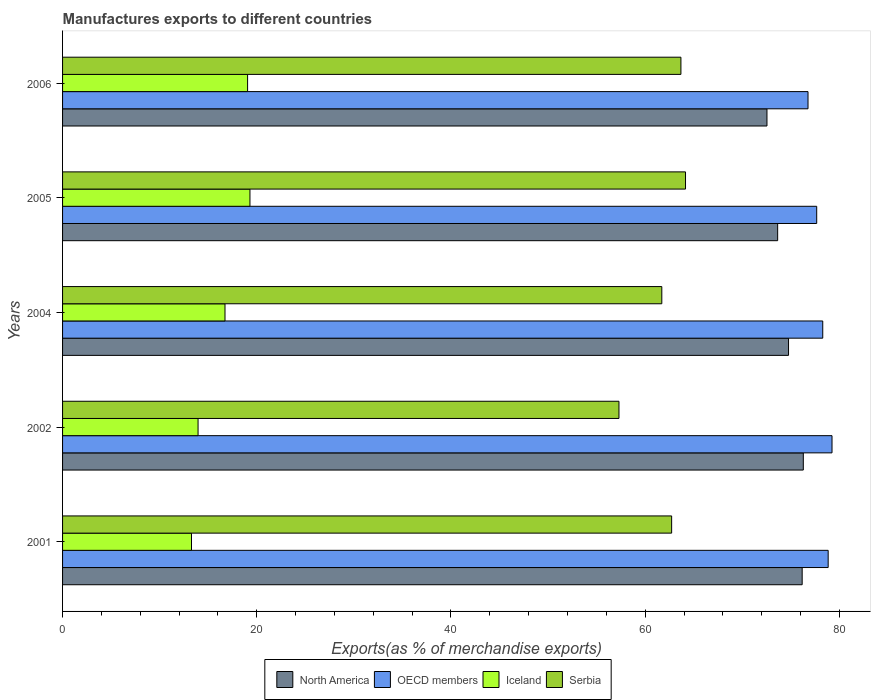Are the number of bars per tick equal to the number of legend labels?
Your answer should be very brief. Yes. How many bars are there on the 1st tick from the top?
Offer a very short reply. 4. In how many cases, is the number of bars for a given year not equal to the number of legend labels?
Ensure brevity in your answer.  0. What is the percentage of exports to different countries in OECD members in 2004?
Make the answer very short. 78.29. Across all years, what is the maximum percentage of exports to different countries in Serbia?
Your response must be concise. 64.15. Across all years, what is the minimum percentage of exports to different countries in North America?
Make the answer very short. 72.54. In which year was the percentage of exports to different countries in North America minimum?
Ensure brevity in your answer.  2006. What is the total percentage of exports to different countries in North America in the graph?
Your answer should be very brief. 373.41. What is the difference between the percentage of exports to different countries in North America in 2002 and that in 2005?
Offer a very short reply. 2.64. What is the difference between the percentage of exports to different countries in North America in 2004 and the percentage of exports to different countries in Serbia in 2002?
Make the answer very short. 17.46. What is the average percentage of exports to different countries in North America per year?
Offer a very short reply. 74.68. In the year 2002, what is the difference between the percentage of exports to different countries in OECD members and percentage of exports to different countries in North America?
Your response must be concise. 2.96. In how many years, is the percentage of exports to different countries in Iceland greater than 56 %?
Make the answer very short. 0. What is the ratio of the percentage of exports to different countries in North America in 2005 to that in 2006?
Provide a succinct answer. 1.02. Is the percentage of exports to different countries in Serbia in 2001 less than that in 2005?
Give a very brief answer. Yes. Is the difference between the percentage of exports to different countries in OECD members in 2004 and 2006 greater than the difference between the percentage of exports to different countries in North America in 2004 and 2006?
Your answer should be very brief. No. What is the difference between the highest and the second highest percentage of exports to different countries in Iceland?
Make the answer very short. 0.24. What is the difference between the highest and the lowest percentage of exports to different countries in Iceland?
Provide a succinct answer. 6.02. Is the sum of the percentage of exports to different countries in OECD members in 2004 and 2005 greater than the maximum percentage of exports to different countries in Iceland across all years?
Your response must be concise. Yes. What does the 4th bar from the bottom in 2006 represents?
Your answer should be very brief. Serbia. Are all the bars in the graph horizontal?
Your response must be concise. Yes. Are the values on the major ticks of X-axis written in scientific E-notation?
Give a very brief answer. No. Does the graph contain any zero values?
Provide a short and direct response. No. Does the graph contain grids?
Provide a succinct answer. No. Where does the legend appear in the graph?
Make the answer very short. Bottom center. How are the legend labels stacked?
Your answer should be compact. Horizontal. What is the title of the graph?
Provide a short and direct response. Manufactures exports to different countries. What is the label or title of the X-axis?
Your answer should be compact. Exports(as % of merchandise exports). What is the Exports(as % of merchandise exports) in North America in 2001?
Provide a short and direct response. 76.17. What is the Exports(as % of merchandise exports) in OECD members in 2001?
Keep it short and to the point. 78.85. What is the Exports(as % of merchandise exports) in Iceland in 2001?
Provide a short and direct response. 13.28. What is the Exports(as % of merchandise exports) in Serbia in 2001?
Make the answer very short. 62.73. What is the Exports(as % of merchandise exports) in North America in 2002?
Provide a short and direct response. 76.29. What is the Exports(as % of merchandise exports) in OECD members in 2002?
Ensure brevity in your answer.  79.24. What is the Exports(as % of merchandise exports) of Iceland in 2002?
Provide a short and direct response. 13.95. What is the Exports(as % of merchandise exports) of Serbia in 2002?
Provide a short and direct response. 57.3. What is the Exports(as % of merchandise exports) in North America in 2004?
Ensure brevity in your answer.  74.76. What is the Exports(as % of merchandise exports) of OECD members in 2004?
Ensure brevity in your answer.  78.29. What is the Exports(as % of merchandise exports) of Iceland in 2004?
Ensure brevity in your answer.  16.73. What is the Exports(as % of merchandise exports) of Serbia in 2004?
Ensure brevity in your answer.  61.71. What is the Exports(as % of merchandise exports) in North America in 2005?
Provide a succinct answer. 73.64. What is the Exports(as % of merchandise exports) of OECD members in 2005?
Your answer should be compact. 77.67. What is the Exports(as % of merchandise exports) of Iceland in 2005?
Provide a succinct answer. 19.3. What is the Exports(as % of merchandise exports) of Serbia in 2005?
Provide a short and direct response. 64.15. What is the Exports(as % of merchandise exports) of North America in 2006?
Offer a very short reply. 72.54. What is the Exports(as % of merchandise exports) of OECD members in 2006?
Your response must be concise. 76.77. What is the Exports(as % of merchandise exports) in Iceland in 2006?
Ensure brevity in your answer.  19.05. What is the Exports(as % of merchandise exports) in Serbia in 2006?
Ensure brevity in your answer.  63.68. Across all years, what is the maximum Exports(as % of merchandise exports) in North America?
Your response must be concise. 76.29. Across all years, what is the maximum Exports(as % of merchandise exports) of OECD members?
Make the answer very short. 79.24. Across all years, what is the maximum Exports(as % of merchandise exports) in Iceland?
Keep it short and to the point. 19.3. Across all years, what is the maximum Exports(as % of merchandise exports) in Serbia?
Provide a short and direct response. 64.15. Across all years, what is the minimum Exports(as % of merchandise exports) in North America?
Your answer should be compact. 72.54. Across all years, what is the minimum Exports(as % of merchandise exports) in OECD members?
Your answer should be very brief. 76.77. Across all years, what is the minimum Exports(as % of merchandise exports) of Iceland?
Provide a succinct answer. 13.28. Across all years, what is the minimum Exports(as % of merchandise exports) in Serbia?
Keep it short and to the point. 57.3. What is the total Exports(as % of merchandise exports) in North America in the graph?
Your answer should be compact. 373.41. What is the total Exports(as % of merchandise exports) in OECD members in the graph?
Your answer should be compact. 390.82. What is the total Exports(as % of merchandise exports) in Iceland in the graph?
Your answer should be compact. 82.31. What is the total Exports(as % of merchandise exports) of Serbia in the graph?
Give a very brief answer. 309.58. What is the difference between the Exports(as % of merchandise exports) of North America in 2001 and that in 2002?
Your answer should be very brief. -0.12. What is the difference between the Exports(as % of merchandise exports) of OECD members in 2001 and that in 2002?
Make the answer very short. -0.4. What is the difference between the Exports(as % of merchandise exports) in Iceland in 2001 and that in 2002?
Make the answer very short. -0.68. What is the difference between the Exports(as % of merchandise exports) of Serbia in 2001 and that in 2002?
Your answer should be very brief. 5.42. What is the difference between the Exports(as % of merchandise exports) in North America in 2001 and that in 2004?
Provide a succinct answer. 1.4. What is the difference between the Exports(as % of merchandise exports) of OECD members in 2001 and that in 2004?
Provide a succinct answer. 0.56. What is the difference between the Exports(as % of merchandise exports) in Iceland in 2001 and that in 2004?
Your answer should be compact. -3.45. What is the difference between the Exports(as % of merchandise exports) in Serbia in 2001 and that in 2004?
Ensure brevity in your answer.  1.01. What is the difference between the Exports(as % of merchandise exports) of North America in 2001 and that in 2005?
Your answer should be compact. 2.52. What is the difference between the Exports(as % of merchandise exports) of OECD members in 2001 and that in 2005?
Your answer should be very brief. 1.18. What is the difference between the Exports(as % of merchandise exports) of Iceland in 2001 and that in 2005?
Give a very brief answer. -6.02. What is the difference between the Exports(as % of merchandise exports) in Serbia in 2001 and that in 2005?
Ensure brevity in your answer.  -1.43. What is the difference between the Exports(as % of merchandise exports) of North America in 2001 and that in 2006?
Your answer should be very brief. 3.63. What is the difference between the Exports(as % of merchandise exports) of OECD members in 2001 and that in 2006?
Your response must be concise. 2.08. What is the difference between the Exports(as % of merchandise exports) in Iceland in 2001 and that in 2006?
Your answer should be very brief. -5.78. What is the difference between the Exports(as % of merchandise exports) in Serbia in 2001 and that in 2006?
Ensure brevity in your answer.  -0.96. What is the difference between the Exports(as % of merchandise exports) in North America in 2002 and that in 2004?
Your answer should be compact. 1.52. What is the difference between the Exports(as % of merchandise exports) of OECD members in 2002 and that in 2004?
Provide a short and direct response. 0.95. What is the difference between the Exports(as % of merchandise exports) in Iceland in 2002 and that in 2004?
Your response must be concise. -2.77. What is the difference between the Exports(as % of merchandise exports) in Serbia in 2002 and that in 2004?
Your response must be concise. -4.41. What is the difference between the Exports(as % of merchandise exports) of North America in 2002 and that in 2005?
Ensure brevity in your answer.  2.64. What is the difference between the Exports(as % of merchandise exports) of OECD members in 2002 and that in 2005?
Make the answer very short. 1.58. What is the difference between the Exports(as % of merchandise exports) of Iceland in 2002 and that in 2005?
Your response must be concise. -5.34. What is the difference between the Exports(as % of merchandise exports) of Serbia in 2002 and that in 2005?
Your answer should be very brief. -6.85. What is the difference between the Exports(as % of merchandise exports) in North America in 2002 and that in 2006?
Your answer should be compact. 3.74. What is the difference between the Exports(as % of merchandise exports) in OECD members in 2002 and that in 2006?
Ensure brevity in your answer.  2.47. What is the difference between the Exports(as % of merchandise exports) in Iceland in 2002 and that in 2006?
Provide a short and direct response. -5.1. What is the difference between the Exports(as % of merchandise exports) in Serbia in 2002 and that in 2006?
Provide a succinct answer. -6.38. What is the difference between the Exports(as % of merchandise exports) in North America in 2004 and that in 2005?
Provide a short and direct response. 1.12. What is the difference between the Exports(as % of merchandise exports) of OECD members in 2004 and that in 2005?
Make the answer very short. 0.62. What is the difference between the Exports(as % of merchandise exports) of Iceland in 2004 and that in 2005?
Your answer should be very brief. -2.57. What is the difference between the Exports(as % of merchandise exports) of Serbia in 2004 and that in 2005?
Your answer should be very brief. -2.44. What is the difference between the Exports(as % of merchandise exports) in North America in 2004 and that in 2006?
Your answer should be very brief. 2.22. What is the difference between the Exports(as % of merchandise exports) in OECD members in 2004 and that in 2006?
Your answer should be very brief. 1.52. What is the difference between the Exports(as % of merchandise exports) of Iceland in 2004 and that in 2006?
Provide a succinct answer. -2.33. What is the difference between the Exports(as % of merchandise exports) in Serbia in 2004 and that in 2006?
Provide a short and direct response. -1.97. What is the difference between the Exports(as % of merchandise exports) in North America in 2005 and that in 2006?
Ensure brevity in your answer.  1.1. What is the difference between the Exports(as % of merchandise exports) in OECD members in 2005 and that in 2006?
Ensure brevity in your answer.  0.89. What is the difference between the Exports(as % of merchandise exports) of Iceland in 2005 and that in 2006?
Ensure brevity in your answer.  0.24. What is the difference between the Exports(as % of merchandise exports) in Serbia in 2005 and that in 2006?
Offer a very short reply. 0.47. What is the difference between the Exports(as % of merchandise exports) of North America in 2001 and the Exports(as % of merchandise exports) of OECD members in 2002?
Provide a succinct answer. -3.07. What is the difference between the Exports(as % of merchandise exports) of North America in 2001 and the Exports(as % of merchandise exports) of Iceland in 2002?
Keep it short and to the point. 62.22. What is the difference between the Exports(as % of merchandise exports) in North America in 2001 and the Exports(as % of merchandise exports) in Serbia in 2002?
Your answer should be very brief. 18.87. What is the difference between the Exports(as % of merchandise exports) of OECD members in 2001 and the Exports(as % of merchandise exports) of Iceland in 2002?
Ensure brevity in your answer.  64.89. What is the difference between the Exports(as % of merchandise exports) in OECD members in 2001 and the Exports(as % of merchandise exports) in Serbia in 2002?
Your answer should be very brief. 21.54. What is the difference between the Exports(as % of merchandise exports) of Iceland in 2001 and the Exports(as % of merchandise exports) of Serbia in 2002?
Your response must be concise. -44.02. What is the difference between the Exports(as % of merchandise exports) in North America in 2001 and the Exports(as % of merchandise exports) in OECD members in 2004?
Offer a very short reply. -2.12. What is the difference between the Exports(as % of merchandise exports) in North America in 2001 and the Exports(as % of merchandise exports) in Iceland in 2004?
Ensure brevity in your answer.  59.44. What is the difference between the Exports(as % of merchandise exports) in North America in 2001 and the Exports(as % of merchandise exports) in Serbia in 2004?
Offer a very short reply. 14.46. What is the difference between the Exports(as % of merchandise exports) in OECD members in 2001 and the Exports(as % of merchandise exports) in Iceland in 2004?
Provide a short and direct response. 62.12. What is the difference between the Exports(as % of merchandise exports) of OECD members in 2001 and the Exports(as % of merchandise exports) of Serbia in 2004?
Offer a terse response. 17.13. What is the difference between the Exports(as % of merchandise exports) of Iceland in 2001 and the Exports(as % of merchandise exports) of Serbia in 2004?
Provide a succinct answer. -48.44. What is the difference between the Exports(as % of merchandise exports) in North America in 2001 and the Exports(as % of merchandise exports) in OECD members in 2005?
Provide a succinct answer. -1.5. What is the difference between the Exports(as % of merchandise exports) of North America in 2001 and the Exports(as % of merchandise exports) of Iceland in 2005?
Your response must be concise. 56.87. What is the difference between the Exports(as % of merchandise exports) of North America in 2001 and the Exports(as % of merchandise exports) of Serbia in 2005?
Your response must be concise. 12.01. What is the difference between the Exports(as % of merchandise exports) of OECD members in 2001 and the Exports(as % of merchandise exports) of Iceland in 2005?
Provide a short and direct response. 59.55. What is the difference between the Exports(as % of merchandise exports) of OECD members in 2001 and the Exports(as % of merchandise exports) of Serbia in 2005?
Give a very brief answer. 14.69. What is the difference between the Exports(as % of merchandise exports) of Iceland in 2001 and the Exports(as % of merchandise exports) of Serbia in 2005?
Your response must be concise. -50.88. What is the difference between the Exports(as % of merchandise exports) of North America in 2001 and the Exports(as % of merchandise exports) of OECD members in 2006?
Provide a succinct answer. -0.6. What is the difference between the Exports(as % of merchandise exports) in North America in 2001 and the Exports(as % of merchandise exports) in Iceland in 2006?
Offer a terse response. 57.11. What is the difference between the Exports(as % of merchandise exports) in North America in 2001 and the Exports(as % of merchandise exports) in Serbia in 2006?
Provide a short and direct response. 12.49. What is the difference between the Exports(as % of merchandise exports) of OECD members in 2001 and the Exports(as % of merchandise exports) of Iceland in 2006?
Provide a short and direct response. 59.79. What is the difference between the Exports(as % of merchandise exports) in OECD members in 2001 and the Exports(as % of merchandise exports) in Serbia in 2006?
Offer a terse response. 15.16. What is the difference between the Exports(as % of merchandise exports) in Iceland in 2001 and the Exports(as % of merchandise exports) in Serbia in 2006?
Ensure brevity in your answer.  -50.4. What is the difference between the Exports(as % of merchandise exports) of North America in 2002 and the Exports(as % of merchandise exports) of OECD members in 2004?
Your response must be concise. -2. What is the difference between the Exports(as % of merchandise exports) of North America in 2002 and the Exports(as % of merchandise exports) of Iceland in 2004?
Provide a succinct answer. 59.56. What is the difference between the Exports(as % of merchandise exports) of North America in 2002 and the Exports(as % of merchandise exports) of Serbia in 2004?
Your answer should be compact. 14.57. What is the difference between the Exports(as % of merchandise exports) in OECD members in 2002 and the Exports(as % of merchandise exports) in Iceland in 2004?
Make the answer very short. 62.51. What is the difference between the Exports(as % of merchandise exports) in OECD members in 2002 and the Exports(as % of merchandise exports) in Serbia in 2004?
Provide a short and direct response. 17.53. What is the difference between the Exports(as % of merchandise exports) in Iceland in 2002 and the Exports(as % of merchandise exports) in Serbia in 2004?
Your answer should be very brief. -47.76. What is the difference between the Exports(as % of merchandise exports) in North America in 2002 and the Exports(as % of merchandise exports) in OECD members in 2005?
Provide a short and direct response. -1.38. What is the difference between the Exports(as % of merchandise exports) of North America in 2002 and the Exports(as % of merchandise exports) of Iceland in 2005?
Your answer should be compact. 56.99. What is the difference between the Exports(as % of merchandise exports) of North America in 2002 and the Exports(as % of merchandise exports) of Serbia in 2005?
Your answer should be compact. 12.13. What is the difference between the Exports(as % of merchandise exports) in OECD members in 2002 and the Exports(as % of merchandise exports) in Iceland in 2005?
Ensure brevity in your answer.  59.94. What is the difference between the Exports(as % of merchandise exports) of OECD members in 2002 and the Exports(as % of merchandise exports) of Serbia in 2005?
Offer a very short reply. 15.09. What is the difference between the Exports(as % of merchandise exports) in Iceland in 2002 and the Exports(as % of merchandise exports) in Serbia in 2005?
Your answer should be very brief. -50.2. What is the difference between the Exports(as % of merchandise exports) in North America in 2002 and the Exports(as % of merchandise exports) in OECD members in 2006?
Your answer should be very brief. -0.49. What is the difference between the Exports(as % of merchandise exports) in North America in 2002 and the Exports(as % of merchandise exports) in Iceland in 2006?
Ensure brevity in your answer.  57.23. What is the difference between the Exports(as % of merchandise exports) in North America in 2002 and the Exports(as % of merchandise exports) in Serbia in 2006?
Give a very brief answer. 12.6. What is the difference between the Exports(as % of merchandise exports) of OECD members in 2002 and the Exports(as % of merchandise exports) of Iceland in 2006?
Ensure brevity in your answer.  60.19. What is the difference between the Exports(as % of merchandise exports) in OECD members in 2002 and the Exports(as % of merchandise exports) in Serbia in 2006?
Give a very brief answer. 15.56. What is the difference between the Exports(as % of merchandise exports) of Iceland in 2002 and the Exports(as % of merchandise exports) of Serbia in 2006?
Give a very brief answer. -49.73. What is the difference between the Exports(as % of merchandise exports) of North America in 2004 and the Exports(as % of merchandise exports) of OECD members in 2005?
Provide a succinct answer. -2.9. What is the difference between the Exports(as % of merchandise exports) in North America in 2004 and the Exports(as % of merchandise exports) in Iceland in 2005?
Keep it short and to the point. 55.47. What is the difference between the Exports(as % of merchandise exports) of North America in 2004 and the Exports(as % of merchandise exports) of Serbia in 2005?
Your response must be concise. 10.61. What is the difference between the Exports(as % of merchandise exports) of OECD members in 2004 and the Exports(as % of merchandise exports) of Iceland in 2005?
Make the answer very short. 58.99. What is the difference between the Exports(as % of merchandise exports) in OECD members in 2004 and the Exports(as % of merchandise exports) in Serbia in 2005?
Offer a terse response. 14.13. What is the difference between the Exports(as % of merchandise exports) of Iceland in 2004 and the Exports(as % of merchandise exports) of Serbia in 2005?
Provide a succinct answer. -47.43. What is the difference between the Exports(as % of merchandise exports) of North America in 2004 and the Exports(as % of merchandise exports) of OECD members in 2006?
Ensure brevity in your answer.  -2.01. What is the difference between the Exports(as % of merchandise exports) of North America in 2004 and the Exports(as % of merchandise exports) of Iceland in 2006?
Ensure brevity in your answer.  55.71. What is the difference between the Exports(as % of merchandise exports) in North America in 2004 and the Exports(as % of merchandise exports) in Serbia in 2006?
Give a very brief answer. 11.08. What is the difference between the Exports(as % of merchandise exports) in OECD members in 2004 and the Exports(as % of merchandise exports) in Iceland in 2006?
Provide a short and direct response. 59.23. What is the difference between the Exports(as % of merchandise exports) in OECD members in 2004 and the Exports(as % of merchandise exports) in Serbia in 2006?
Offer a very short reply. 14.61. What is the difference between the Exports(as % of merchandise exports) in Iceland in 2004 and the Exports(as % of merchandise exports) in Serbia in 2006?
Offer a very short reply. -46.95. What is the difference between the Exports(as % of merchandise exports) of North America in 2005 and the Exports(as % of merchandise exports) of OECD members in 2006?
Your answer should be very brief. -3.13. What is the difference between the Exports(as % of merchandise exports) of North America in 2005 and the Exports(as % of merchandise exports) of Iceland in 2006?
Your response must be concise. 54.59. What is the difference between the Exports(as % of merchandise exports) of North America in 2005 and the Exports(as % of merchandise exports) of Serbia in 2006?
Offer a very short reply. 9.96. What is the difference between the Exports(as % of merchandise exports) in OECD members in 2005 and the Exports(as % of merchandise exports) in Iceland in 2006?
Your answer should be compact. 58.61. What is the difference between the Exports(as % of merchandise exports) in OECD members in 2005 and the Exports(as % of merchandise exports) in Serbia in 2006?
Your response must be concise. 13.98. What is the difference between the Exports(as % of merchandise exports) in Iceland in 2005 and the Exports(as % of merchandise exports) in Serbia in 2006?
Offer a terse response. -44.38. What is the average Exports(as % of merchandise exports) of North America per year?
Provide a succinct answer. 74.68. What is the average Exports(as % of merchandise exports) of OECD members per year?
Your answer should be very brief. 78.16. What is the average Exports(as % of merchandise exports) in Iceland per year?
Ensure brevity in your answer.  16.46. What is the average Exports(as % of merchandise exports) of Serbia per year?
Your response must be concise. 61.92. In the year 2001, what is the difference between the Exports(as % of merchandise exports) of North America and Exports(as % of merchandise exports) of OECD members?
Provide a short and direct response. -2.68. In the year 2001, what is the difference between the Exports(as % of merchandise exports) in North America and Exports(as % of merchandise exports) in Iceland?
Give a very brief answer. 62.89. In the year 2001, what is the difference between the Exports(as % of merchandise exports) of North America and Exports(as % of merchandise exports) of Serbia?
Offer a very short reply. 13.44. In the year 2001, what is the difference between the Exports(as % of merchandise exports) of OECD members and Exports(as % of merchandise exports) of Iceland?
Your response must be concise. 65.57. In the year 2001, what is the difference between the Exports(as % of merchandise exports) of OECD members and Exports(as % of merchandise exports) of Serbia?
Your answer should be very brief. 16.12. In the year 2001, what is the difference between the Exports(as % of merchandise exports) of Iceland and Exports(as % of merchandise exports) of Serbia?
Ensure brevity in your answer.  -49.45. In the year 2002, what is the difference between the Exports(as % of merchandise exports) of North America and Exports(as % of merchandise exports) of OECD members?
Your response must be concise. -2.96. In the year 2002, what is the difference between the Exports(as % of merchandise exports) of North America and Exports(as % of merchandise exports) of Iceland?
Provide a succinct answer. 62.33. In the year 2002, what is the difference between the Exports(as % of merchandise exports) in North America and Exports(as % of merchandise exports) in Serbia?
Provide a short and direct response. 18.98. In the year 2002, what is the difference between the Exports(as % of merchandise exports) in OECD members and Exports(as % of merchandise exports) in Iceland?
Ensure brevity in your answer.  65.29. In the year 2002, what is the difference between the Exports(as % of merchandise exports) of OECD members and Exports(as % of merchandise exports) of Serbia?
Make the answer very short. 21.94. In the year 2002, what is the difference between the Exports(as % of merchandise exports) of Iceland and Exports(as % of merchandise exports) of Serbia?
Provide a succinct answer. -43.35. In the year 2004, what is the difference between the Exports(as % of merchandise exports) in North America and Exports(as % of merchandise exports) in OECD members?
Give a very brief answer. -3.52. In the year 2004, what is the difference between the Exports(as % of merchandise exports) of North America and Exports(as % of merchandise exports) of Iceland?
Provide a short and direct response. 58.04. In the year 2004, what is the difference between the Exports(as % of merchandise exports) in North America and Exports(as % of merchandise exports) in Serbia?
Give a very brief answer. 13.05. In the year 2004, what is the difference between the Exports(as % of merchandise exports) of OECD members and Exports(as % of merchandise exports) of Iceland?
Make the answer very short. 61.56. In the year 2004, what is the difference between the Exports(as % of merchandise exports) of OECD members and Exports(as % of merchandise exports) of Serbia?
Keep it short and to the point. 16.58. In the year 2004, what is the difference between the Exports(as % of merchandise exports) in Iceland and Exports(as % of merchandise exports) in Serbia?
Make the answer very short. -44.98. In the year 2005, what is the difference between the Exports(as % of merchandise exports) in North America and Exports(as % of merchandise exports) in OECD members?
Offer a very short reply. -4.02. In the year 2005, what is the difference between the Exports(as % of merchandise exports) of North America and Exports(as % of merchandise exports) of Iceland?
Provide a succinct answer. 54.35. In the year 2005, what is the difference between the Exports(as % of merchandise exports) of North America and Exports(as % of merchandise exports) of Serbia?
Offer a terse response. 9.49. In the year 2005, what is the difference between the Exports(as % of merchandise exports) in OECD members and Exports(as % of merchandise exports) in Iceland?
Offer a very short reply. 58.37. In the year 2005, what is the difference between the Exports(as % of merchandise exports) of OECD members and Exports(as % of merchandise exports) of Serbia?
Make the answer very short. 13.51. In the year 2005, what is the difference between the Exports(as % of merchandise exports) in Iceland and Exports(as % of merchandise exports) in Serbia?
Ensure brevity in your answer.  -44.86. In the year 2006, what is the difference between the Exports(as % of merchandise exports) in North America and Exports(as % of merchandise exports) in OECD members?
Offer a very short reply. -4.23. In the year 2006, what is the difference between the Exports(as % of merchandise exports) in North America and Exports(as % of merchandise exports) in Iceland?
Provide a short and direct response. 53.49. In the year 2006, what is the difference between the Exports(as % of merchandise exports) in North America and Exports(as % of merchandise exports) in Serbia?
Keep it short and to the point. 8.86. In the year 2006, what is the difference between the Exports(as % of merchandise exports) of OECD members and Exports(as % of merchandise exports) of Iceland?
Ensure brevity in your answer.  57.72. In the year 2006, what is the difference between the Exports(as % of merchandise exports) in OECD members and Exports(as % of merchandise exports) in Serbia?
Offer a terse response. 13.09. In the year 2006, what is the difference between the Exports(as % of merchandise exports) in Iceland and Exports(as % of merchandise exports) in Serbia?
Give a very brief answer. -44.63. What is the ratio of the Exports(as % of merchandise exports) in Iceland in 2001 to that in 2002?
Ensure brevity in your answer.  0.95. What is the ratio of the Exports(as % of merchandise exports) in Serbia in 2001 to that in 2002?
Make the answer very short. 1.09. What is the ratio of the Exports(as % of merchandise exports) of North America in 2001 to that in 2004?
Give a very brief answer. 1.02. What is the ratio of the Exports(as % of merchandise exports) in OECD members in 2001 to that in 2004?
Keep it short and to the point. 1.01. What is the ratio of the Exports(as % of merchandise exports) in Iceland in 2001 to that in 2004?
Offer a very short reply. 0.79. What is the ratio of the Exports(as % of merchandise exports) in Serbia in 2001 to that in 2004?
Give a very brief answer. 1.02. What is the ratio of the Exports(as % of merchandise exports) of North America in 2001 to that in 2005?
Your answer should be very brief. 1.03. What is the ratio of the Exports(as % of merchandise exports) of OECD members in 2001 to that in 2005?
Provide a succinct answer. 1.02. What is the ratio of the Exports(as % of merchandise exports) of Iceland in 2001 to that in 2005?
Offer a terse response. 0.69. What is the ratio of the Exports(as % of merchandise exports) of Serbia in 2001 to that in 2005?
Your response must be concise. 0.98. What is the ratio of the Exports(as % of merchandise exports) in OECD members in 2001 to that in 2006?
Provide a short and direct response. 1.03. What is the ratio of the Exports(as % of merchandise exports) in Iceland in 2001 to that in 2006?
Offer a very short reply. 0.7. What is the ratio of the Exports(as % of merchandise exports) of Serbia in 2001 to that in 2006?
Provide a short and direct response. 0.98. What is the ratio of the Exports(as % of merchandise exports) of North America in 2002 to that in 2004?
Give a very brief answer. 1.02. What is the ratio of the Exports(as % of merchandise exports) of OECD members in 2002 to that in 2004?
Ensure brevity in your answer.  1.01. What is the ratio of the Exports(as % of merchandise exports) in Iceland in 2002 to that in 2004?
Give a very brief answer. 0.83. What is the ratio of the Exports(as % of merchandise exports) of Serbia in 2002 to that in 2004?
Provide a short and direct response. 0.93. What is the ratio of the Exports(as % of merchandise exports) of North America in 2002 to that in 2005?
Your response must be concise. 1.04. What is the ratio of the Exports(as % of merchandise exports) in OECD members in 2002 to that in 2005?
Keep it short and to the point. 1.02. What is the ratio of the Exports(as % of merchandise exports) in Iceland in 2002 to that in 2005?
Your answer should be compact. 0.72. What is the ratio of the Exports(as % of merchandise exports) in Serbia in 2002 to that in 2005?
Offer a very short reply. 0.89. What is the ratio of the Exports(as % of merchandise exports) in North America in 2002 to that in 2006?
Keep it short and to the point. 1.05. What is the ratio of the Exports(as % of merchandise exports) in OECD members in 2002 to that in 2006?
Your answer should be compact. 1.03. What is the ratio of the Exports(as % of merchandise exports) in Iceland in 2002 to that in 2006?
Ensure brevity in your answer.  0.73. What is the ratio of the Exports(as % of merchandise exports) of Serbia in 2002 to that in 2006?
Your response must be concise. 0.9. What is the ratio of the Exports(as % of merchandise exports) of North America in 2004 to that in 2005?
Provide a succinct answer. 1.02. What is the ratio of the Exports(as % of merchandise exports) of Iceland in 2004 to that in 2005?
Keep it short and to the point. 0.87. What is the ratio of the Exports(as % of merchandise exports) of Serbia in 2004 to that in 2005?
Your answer should be very brief. 0.96. What is the ratio of the Exports(as % of merchandise exports) in North America in 2004 to that in 2006?
Offer a terse response. 1.03. What is the ratio of the Exports(as % of merchandise exports) in OECD members in 2004 to that in 2006?
Give a very brief answer. 1.02. What is the ratio of the Exports(as % of merchandise exports) of Iceland in 2004 to that in 2006?
Give a very brief answer. 0.88. What is the ratio of the Exports(as % of merchandise exports) in Serbia in 2004 to that in 2006?
Make the answer very short. 0.97. What is the ratio of the Exports(as % of merchandise exports) in North America in 2005 to that in 2006?
Your answer should be very brief. 1.02. What is the ratio of the Exports(as % of merchandise exports) of OECD members in 2005 to that in 2006?
Give a very brief answer. 1.01. What is the ratio of the Exports(as % of merchandise exports) in Iceland in 2005 to that in 2006?
Ensure brevity in your answer.  1.01. What is the ratio of the Exports(as % of merchandise exports) of Serbia in 2005 to that in 2006?
Give a very brief answer. 1.01. What is the difference between the highest and the second highest Exports(as % of merchandise exports) of North America?
Your answer should be very brief. 0.12. What is the difference between the highest and the second highest Exports(as % of merchandise exports) in OECD members?
Keep it short and to the point. 0.4. What is the difference between the highest and the second highest Exports(as % of merchandise exports) of Iceland?
Give a very brief answer. 0.24. What is the difference between the highest and the second highest Exports(as % of merchandise exports) of Serbia?
Give a very brief answer. 0.47. What is the difference between the highest and the lowest Exports(as % of merchandise exports) of North America?
Provide a short and direct response. 3.74. What is the difference between the highest and the lowest Exports(as % of merchandise exports) of OECD members?
Your answer should be compact. 2.47. What is the difference between the highest and the lowest Exports(as % of merchandise exports) in Iceland?
Give a very brief answer. 6.02. What is the difference between the highest and the lowest Exports(as % of merchandise exports) of Serbia?
Make the answer very short. 6.85. 